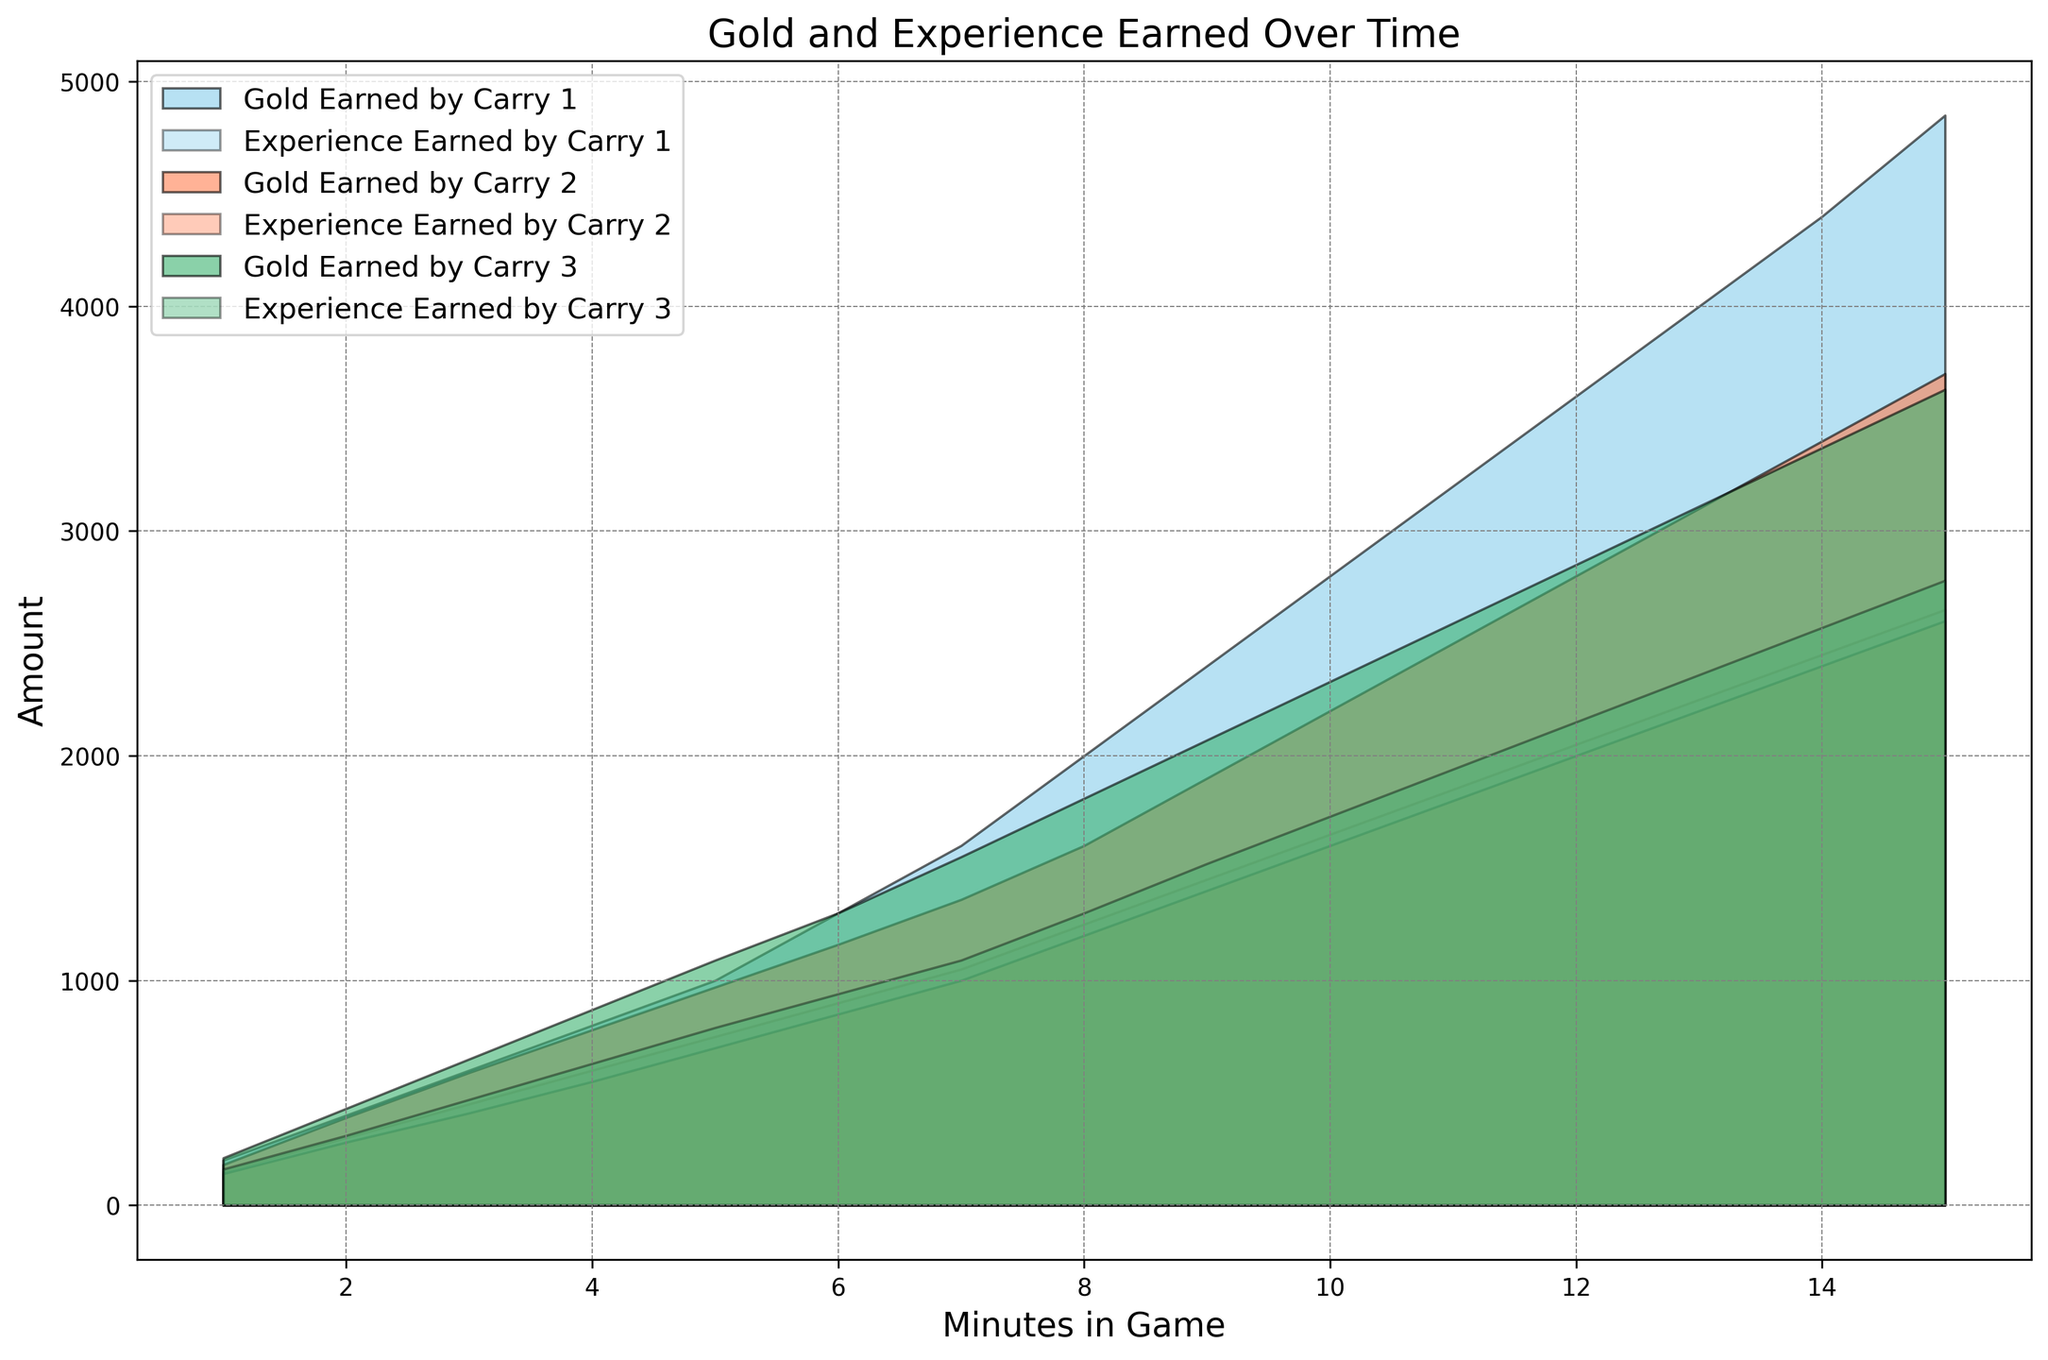Which carry hero earned the most gold by the end of the match? By examining the end points of each area chart for gold earned, compare the values. Carry 1 reaches 4850 gold, Carry 2 reaches 3700 gold, and Carry 3 reaches 3630 gold.
Answer: Carry 1 Which carry hero experienced the fastest growth in experience earned during the first 3 minutes of the game? Check the slopes of the experience earned lines for each carry hero in the initial 3 minutes. Carry 1 reaches 450 experience, Carry 2 reaches 410 experience, and Carry 3 reaches 470 experience.
Answer: Carry 3 At the 10-minute mark, which carry hero has less experience earned compared to the other two? Look at the experience earned values at the 10-minute mark for all carry heroes. Carry 1 has 1650, Carry 2 has 1600, and Carry 3 has 1730.
Answer: Carry 2 By how much did Carry 1's gold earned increase between the 5th and the 15th minute? Subtract the gold earned by Carry 1 at the 5th minute from the 15th minute. At the 5th minute, it’s 1000 gold, and at the 15th minute, it’s 4850 gold. So, 4850 - 1000 = 3850.
Answer: 3850 How does the experience earned by Carry 2 at the 8-minute mark compare to Carry 3 at the same time? Compare the experience earned by both carry heroes at the 8-minute mark. Carry 2 earns 1200 experience, and Carry 3 earns 1300 experience.
Answer: Carry 3 Which carry hero had the steepest increase in gold earned between the 9th and 11th minutes? Check the slopes for the gold earned lines between the 9th and 11th minutes for each carry hero. Calculate the difference in gold earned in this interval: Carry 1 (3200 - 2400 = 800), Carry 2 (2500 - 1900 = 600), Carry 3 (2590 - 2070 = 520).
Answer: Carry 1 How much experience did Carry 3 earn by the end of the match compared to Carry 1? Compare the experience earned by both carry heroes at the 15-minute mark. Carry 3 earns 2780 experience, and Carry 1 earns 2650 experience.
Answer: 130 At the 12th minute, which carry hero has the highest combined total of gold and experience earned? Calculate the combined total of gold and experience earned at the 12th minute for each carry hero. Carry 1: 3600 + 2050 = 5650, Carry 2: 2800 + 2000 = 4800, Carry 3: 2850 + 2150 = 5000.
Answer: Carry 1 Which support hero supported the carry hero that earned the highest total gold throughout the match? Identify the support hero paired with the carry hero who earned the most gold (Carry 1 with 4850 gold). The support hero is Support 1.
Answer: Support 1 